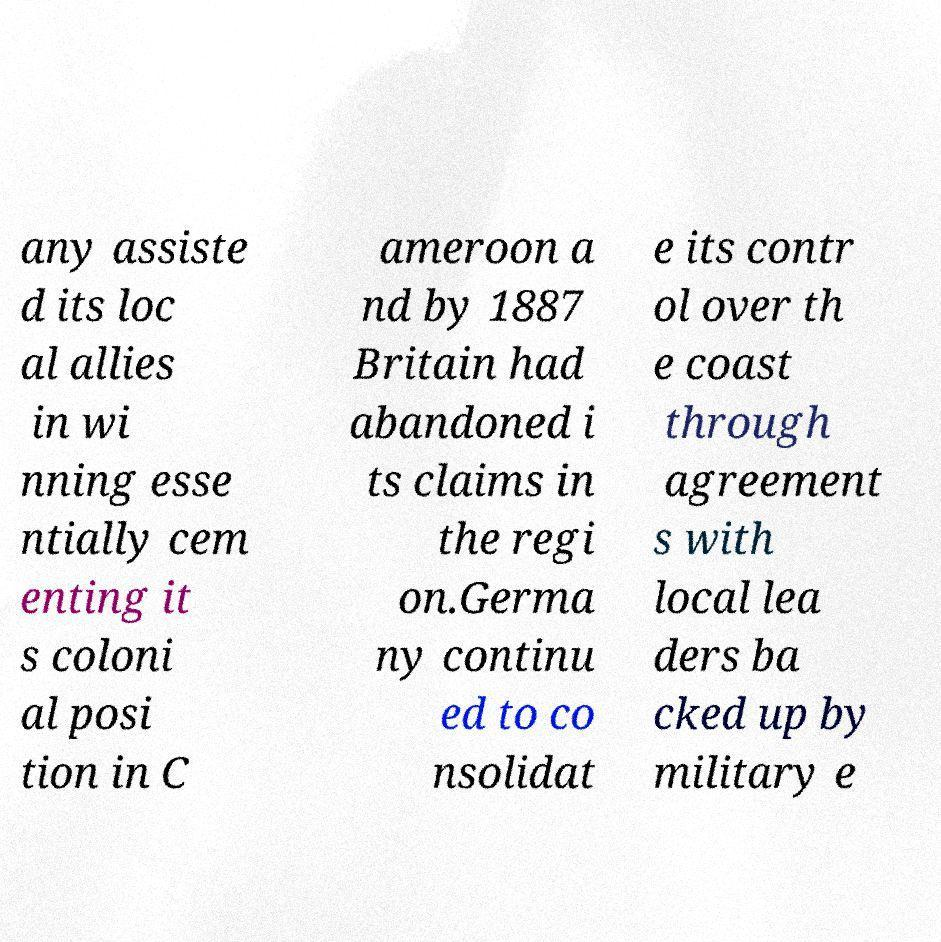Can you read and provide the text displayed in the image?This photo seems to have some interesting text. Can you extract and type it out for me? any assiste d its loc al allies in wi nning esse ntially cem enting it s coloni al posi tion in C ameroon a nd by 1887 Britain had abandoned i ts claims in the regi on.Germa ny continu ed to co nsolidat e its contr ol over th e coast through agreement s with local lea ders ba cked up by military e 